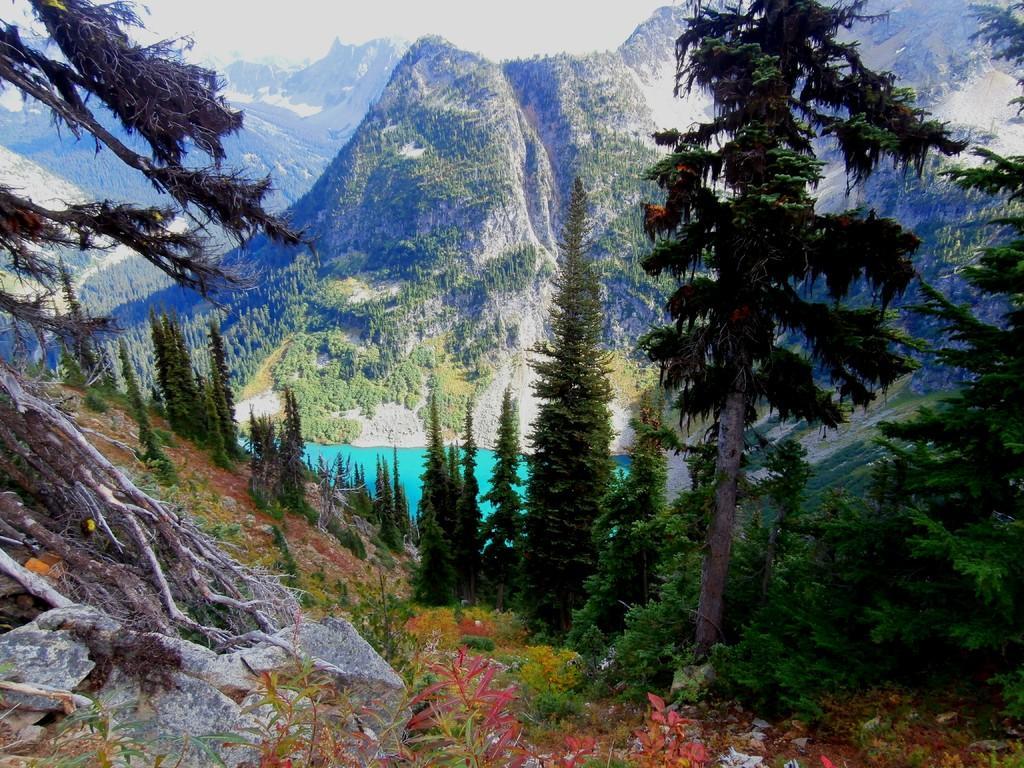In one or two sentences, can you explain what this image depicts? In this image, we can see trees, hills, rocks, plants and there is water. 